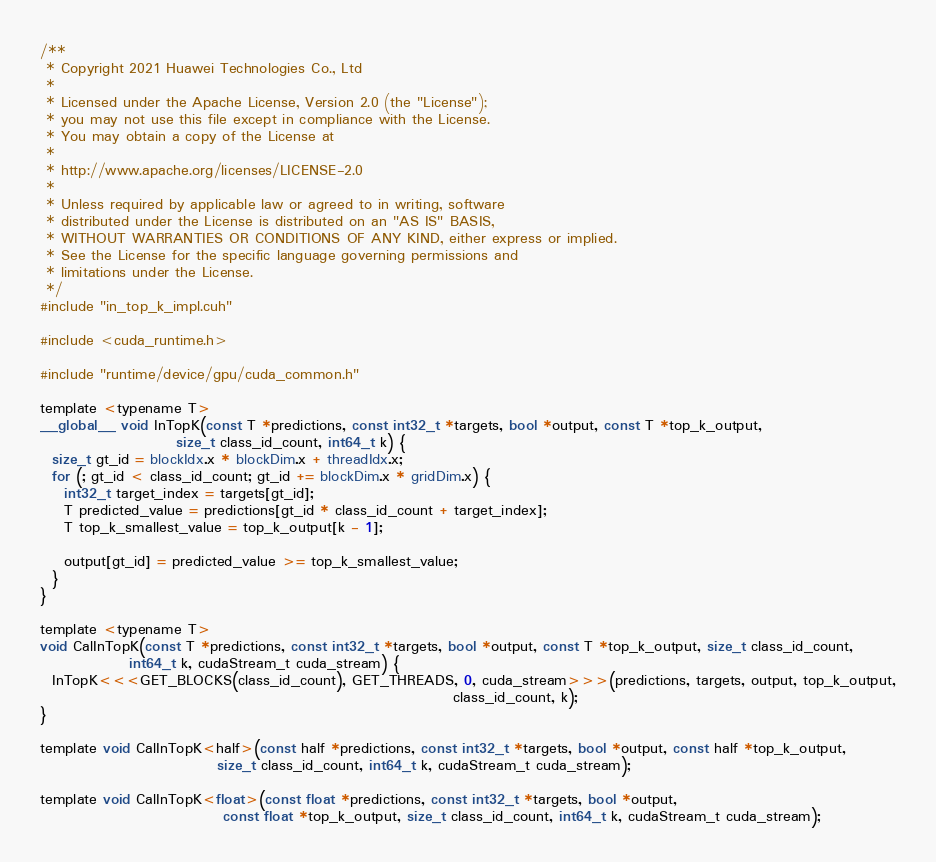<code> <loc_0><loc_0><loc_500><loc_500><_Cuda_>/**
 * Copyright 2021 Huawei Technologies Co., Ltd
 *
 * Licensed under the Apache License, Version 2.0 (the "License");
 * you may not use this file except in compliance with the License.
 * You may obtain a copy of the License at
 *
 * http://www.apache.org/licenses/LICENSE-2.0
 *
 * Unless required by applicable law or agreed to in writing, software
 * distributed under the License is distributed on an "AS IS" BASIS,
 * WITHOUT WARRANTIES OR CONDITIONS OF ANY KIND, either express or implied.
 * See the License for the specific language governing permissions and
 * limitations under the License.
 */
#include "in_top_k_impl.cuh"

#include <cuda_runtime.h>

#include "runtime/device/gpu/cuda_common.h"

template <typename T>
__global__ void InTopK(const T *predictions, const int32_t *targets, bool *output, const T *top_k_output,
                       size_t class_id_count, int64_t k) {
  size_t gt_id = blockIdx.x * blockDim.x + threadIdx.x;
  for (; gt_id < class_id_count; gt_id += blockDim.x * gridDim.x) {
    int32_t target_index = targets[gt_id];
    T predicted_value = predictions[gt_id * class_id_count + target_index];
    T top_k_smallest_value = top_k_output[k - 1];

    output[gt_id] = predicted_value >= top_k_smallest_value;
  }
}

template <typename T>
void CalInTopK(const T *predictions, const int32_t *targets, bool *output, const T *top_k_output, size_t class_id_count,
               int64_t k, cudaStream_t cuda_stream) {
  InTopK<<<GET_BLOCKS(class_id_count), GET_THREADS, 0, cuda_stream>>>(predictions, targets, output, top_k_output,
                                                                      class_id_count, k);
}

template void CalInTopK<half>(const half *predictions, const int32_t *targets, bool *output, const half *top_k_output,
                              size_t class_id_count, int64_t k, cudaStream_t cuda_stream);

template void CalInTopK<float>(const float *predictions, const int32_t *targets, bool *output,
                               const float *top_k_output, size_t class_id_count, int64_t k, cudaStream_t cuda_stream);
</code> 